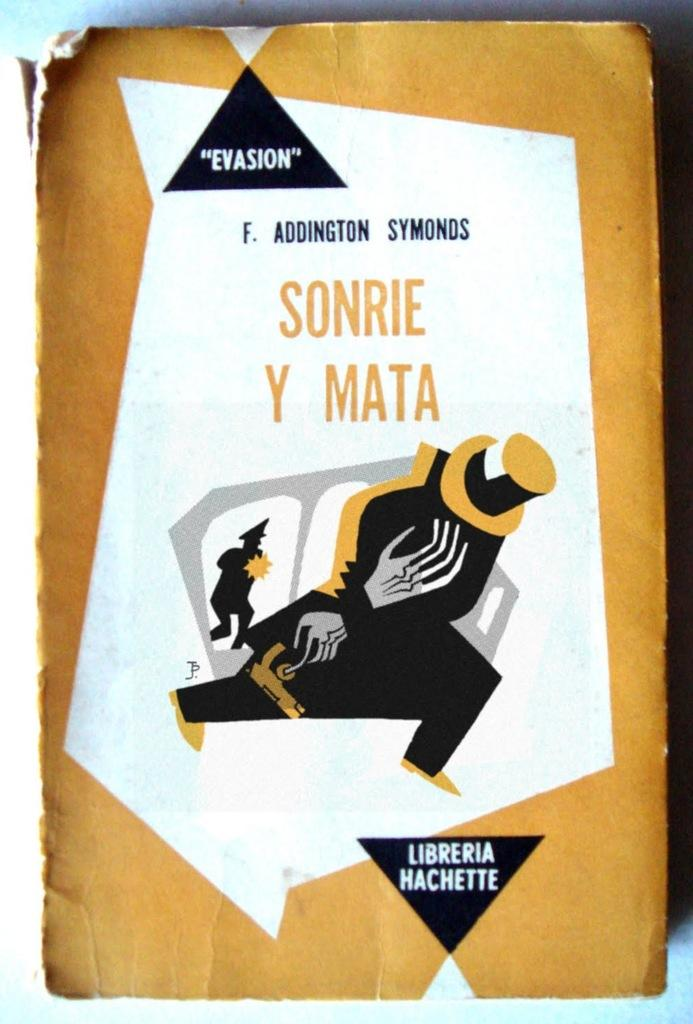Provide a one-sentence caption for the provided image. the word sonrie that is on a white background. 